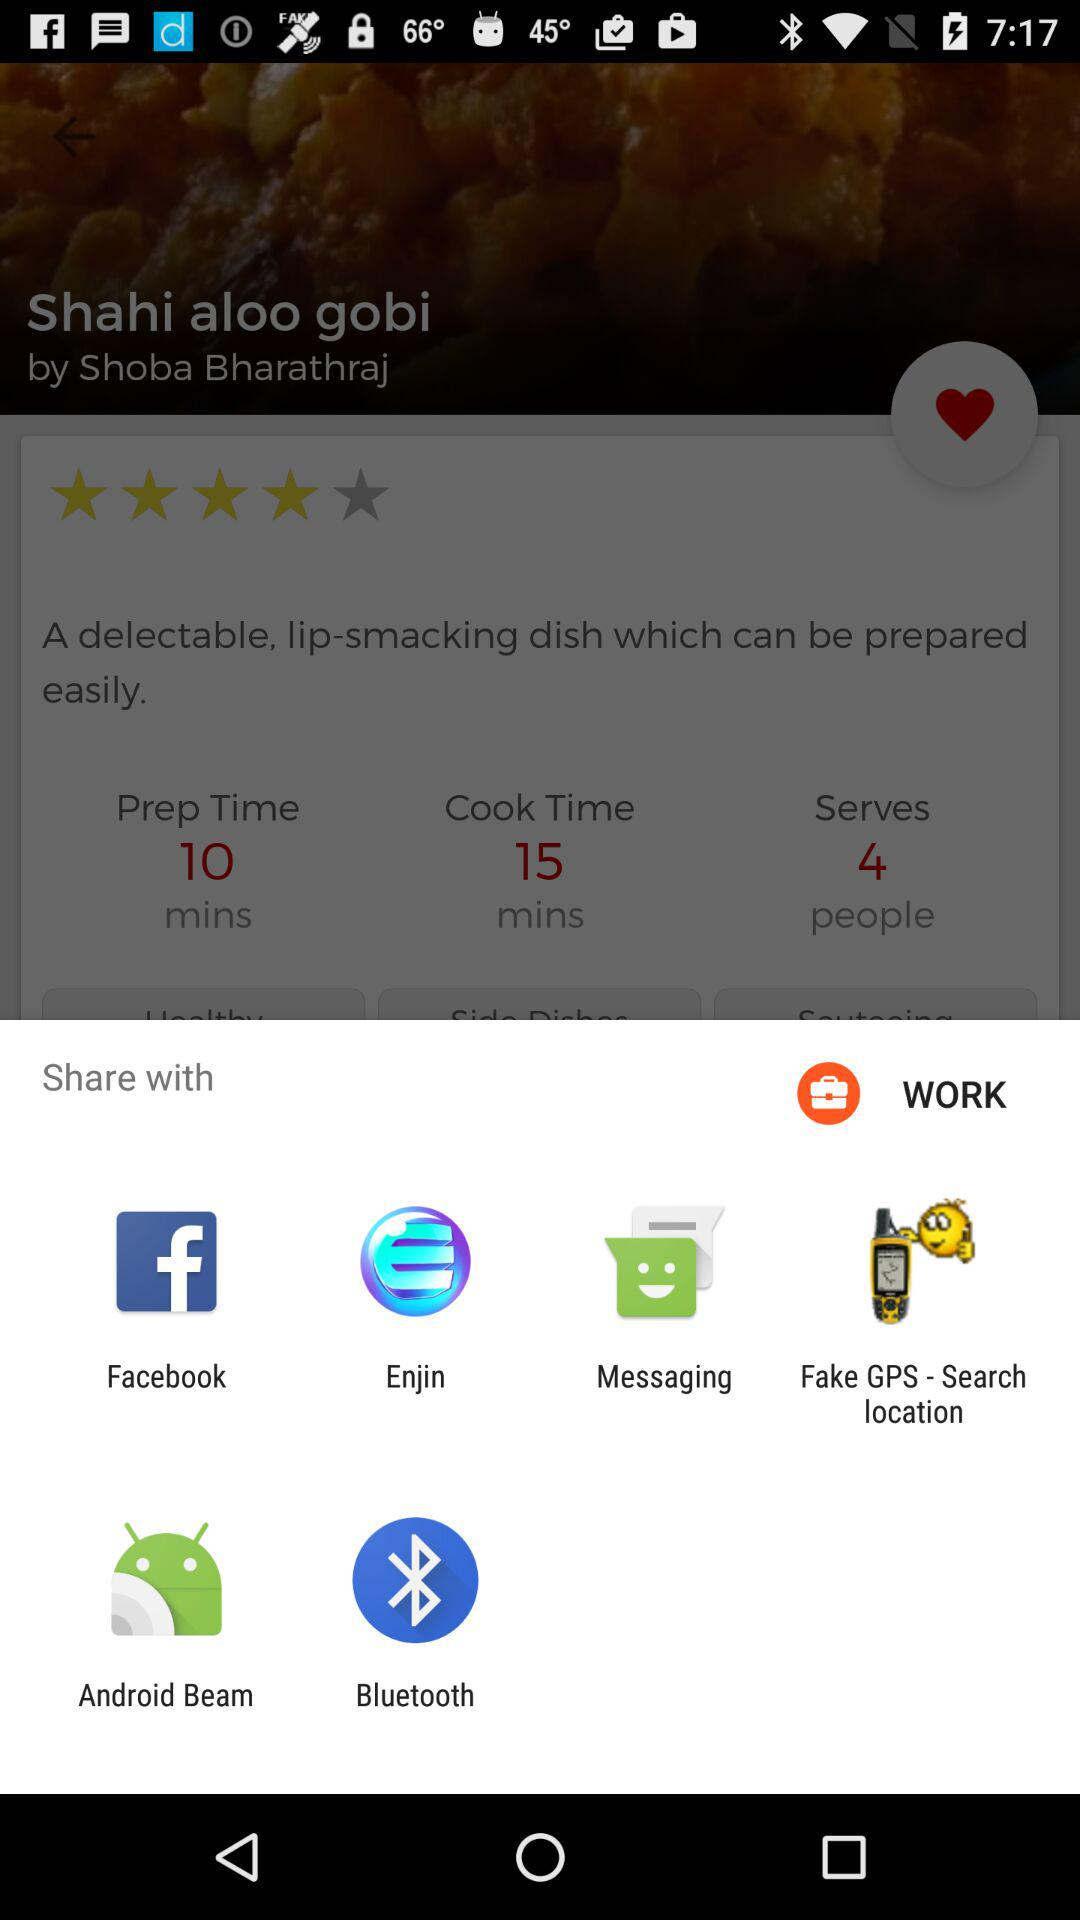What is the preparation time for Shahi aloo gobi? The preparation time is 10 minutes. 